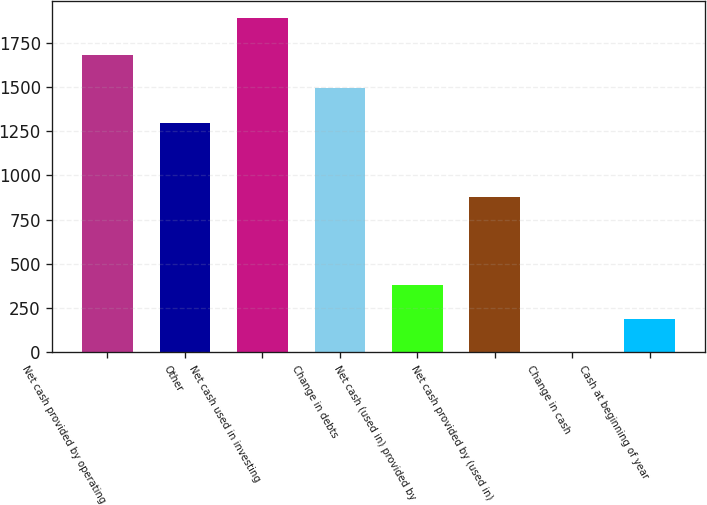Convert chart to OTSL. <chart><loc_0><loc_0><loc_500><loc_500><bar_chart><fcel>Net cash provided by operating<fcel>Other<fcel>Net cash used in investing<fcel>Change in debts<fcel>Net cash (used in) provided by<fcel>Net cash provided by (used in)<fcel>Change in cash<fcel>Cash at beginning of year<nl><fcel>1682.1<fcel>1294<fcel>1892<fcel>1493<fcel>379.2<fcel>877<fcel>1<fcel>190.1<nl></chart> 